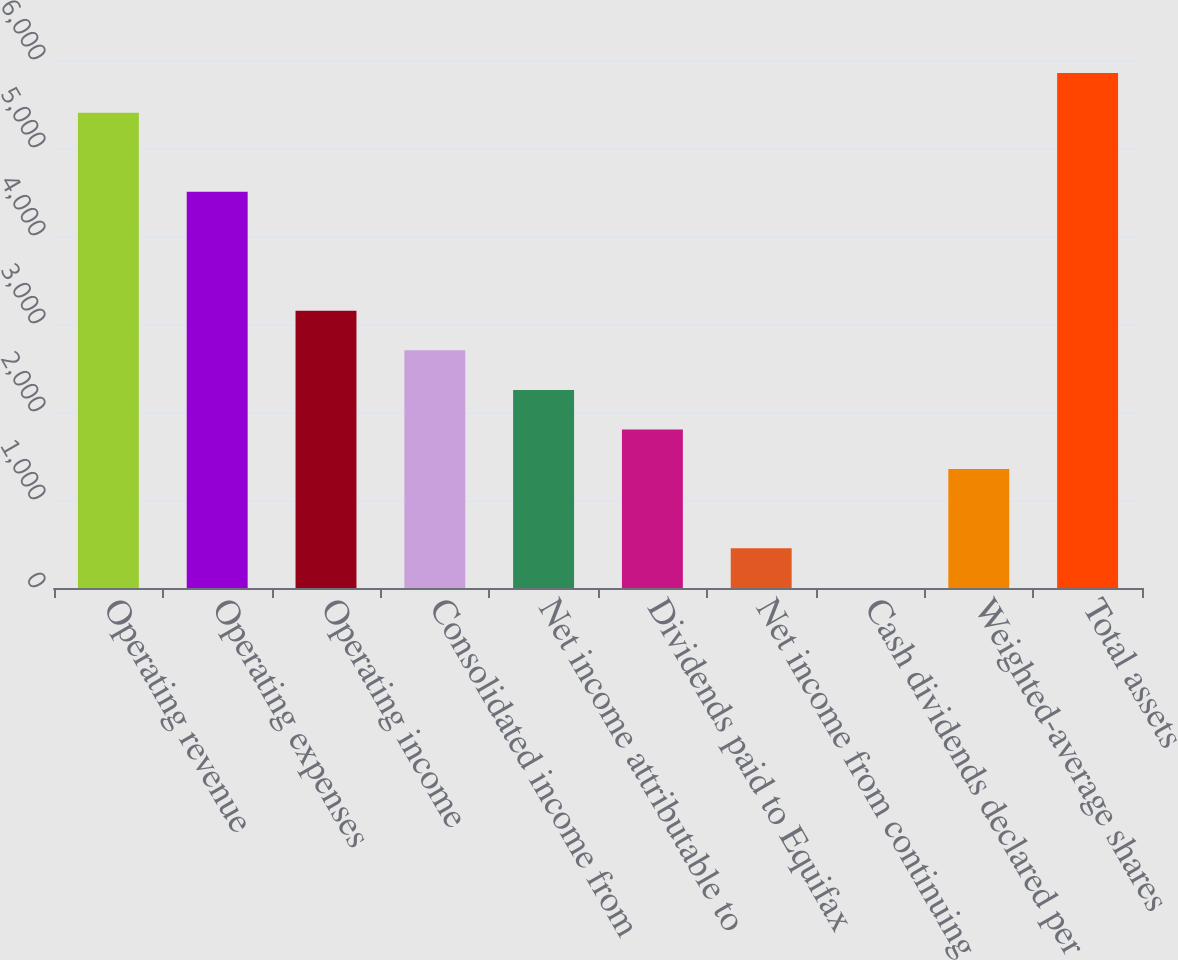<chart> <loc_0><loc_0><loc_500><loc_500><bar_chart><fcel>Operating revenue<fcel>Operating expenses<fcel>Operating income<fcel>Consolidated income from<fcel>Net income attributable to<fcel>Dividends paid to Equifax<fcel>Net income from continuing<fcel>Cash dividends declared per<fcel>Weighted-average shares<fcel>Total assets<nl><fcel>5401.52<fcel>4501.46<fcel>3151.37<fcel>2701.34<fcel>2251.31<fcel>1801.28<fcel>451.19<fcel>1.16<fcel>1351.25<fcel>5851.55<nl></chart> 